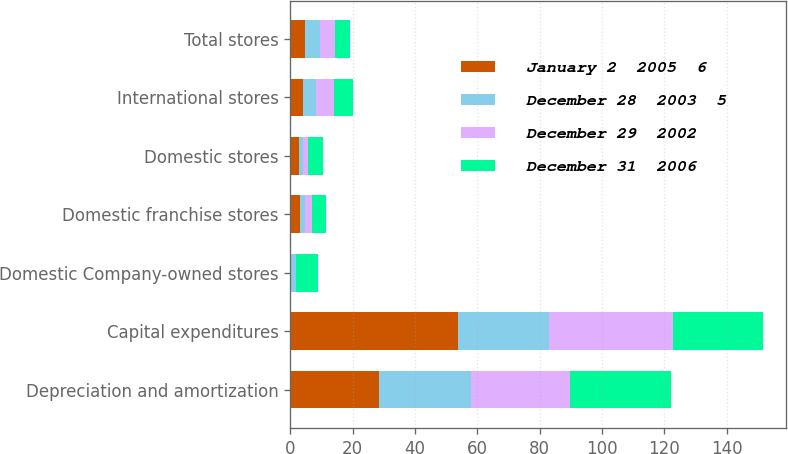<chart> <loc_0><loc_0><loc_500><loc_500><stacked_bar_chart><ecel><fcel>Depreciation and amortization<fcel>Capital expenditures<fcel>Domestic Company-owned stores<fcel>Domestic franchise stores<fcel>Domestic stores<fcel>International stores<fcel>Total stores<nl><fcel>January 2  2005  6<fcel>28.3<fcel>53.9<fcel>0<fcel>3<fcel>2.6<fcel>4.1<fcel>4.75<nl><fcel>December 28  2003  5<fcel>29.8<fcel>29.2<fcel>1.7<fcel>1.7<fcel>1.3<fcel>4<fcel>4.75<nl><fcel>December 29  2002<fcel>31.7<fcel>39.8<fcel>0.1<fcel>2.1<fcel>1.8<fcel>5.9<fcel>4.75<nl><fcel>December 31  2006<fcel>32.4<fcel>28.7<fcel>7.1<fcel>4.6<fcel>4.9<fcel>6.1<fcel>4.75<nl></chart> 